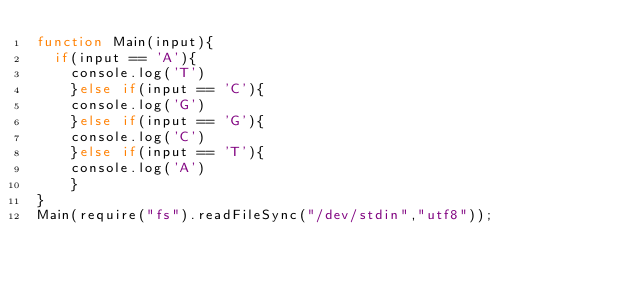Convert code to text. <code><loc_0><loc_0><loc_500><loc_500><_JavaScript_>function Main(input){
	if(input == 'A'){
    console.log('T')
    }else if(input == 'C'){
    console.log('G')
    }else if(input == 'G'){
    console.log('C')
    }else if(input == 'T'){
    console.log('A')
    }
}
Main(require("fs").readFileSync("/dev/stdin","utf8"));</code> 